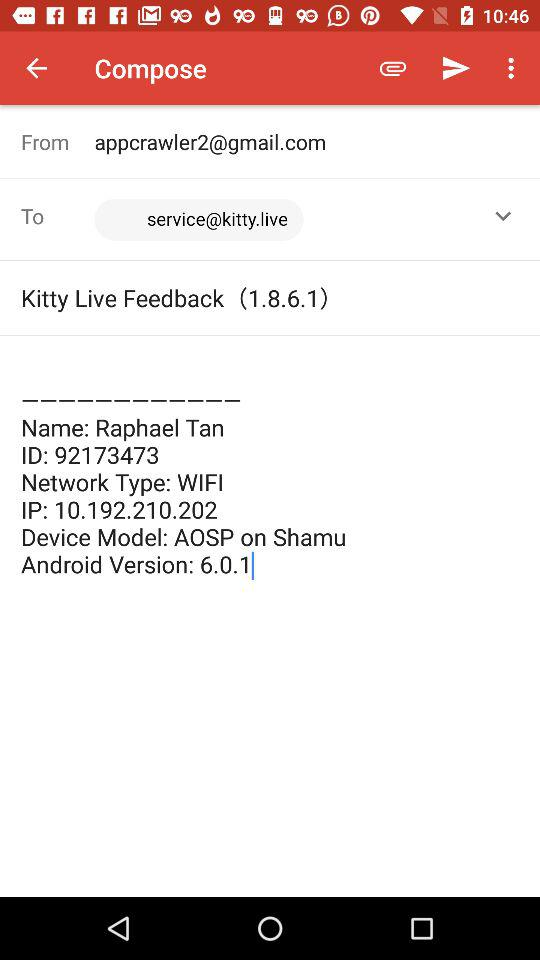What is the id? The id is 92173473. 